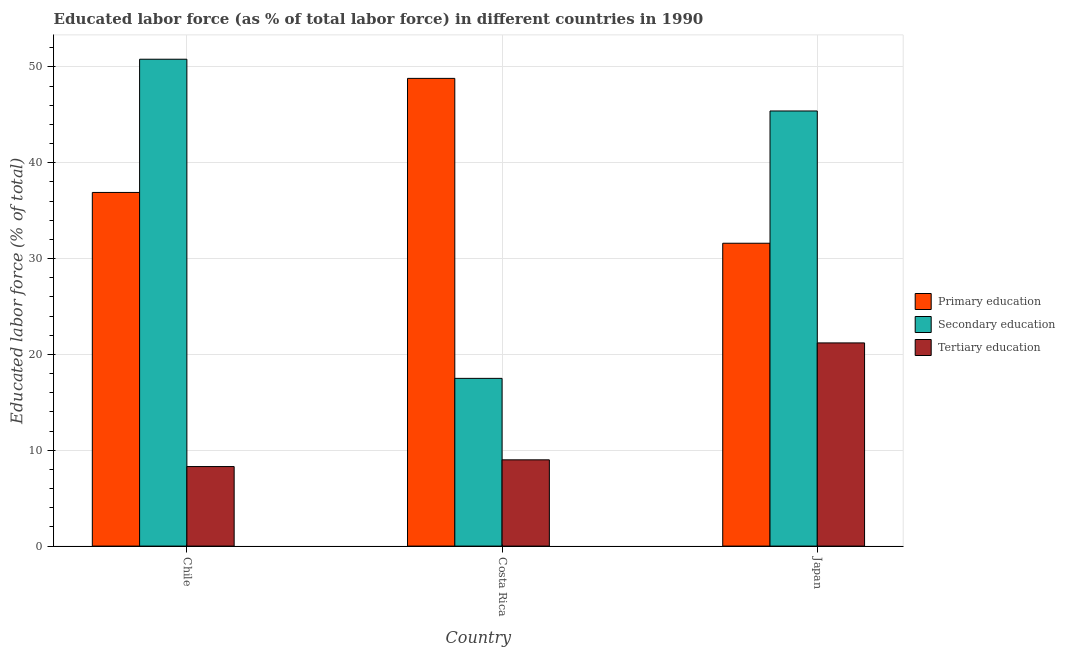How many groups of bars are there?
Make the answer very short. 3. Are the number of bars per tick equal to the number of legend labels?
Make the answer very short. Yes. How many bars are there on the 3rd tick from the right?
Make the answer very short. 3. What is the label of the 2nd group of bars from the left?
Keep it short and to the point. Costa Rica. What is the percentage of labor force who received primary education in Japan?
Ensure brevity in your answer.  31.6. Across all countries, what is the maximum percentage of labor force who received primary education?
Offer a terse response. 48.8. In which country was the percentage of labor force who received tertiary education maximum?
Ensure brevity in your answer.  Japan. What is the total percentage of labor force who received secondary education in the graph?
Provide a succinct answer. 113.7. What is the difference between the percentage of labor force who received secondary education in Chile and that in Costa Rica?
Your answer should be very brief. 33.3. What is the difference between the percentage of labor force who received primary education in Chile and the percentage of labor force who received tertiary education in Costa Rica?
Provide a short and direct response. 27.9. What is the average percentage of labor force who received secondary education per country?
Keep it short and to the point. 37.9. What is the difference between the percentage of labor force who received tertiary education and percentage of labor force who received secondary education in Japan?
Offer a very short reply. -24.2. What is the ratio of the percentage of labor force who received secondary education in Costa Rica to that in Japan?
Your answer should be compact. 0.39. Is the difference between the percentage of labor force who received primary education in Chile and Costa Rica greater than the difference between the percentage of labor force who received secondary education in Chile and Costa Rica?
Provide a succinct answer. No. What is the difference between the highest and the second highest percentage of labor force who received tertiary education?
Your answer should be very brief. 12.2. What is the difference between the highest and the lowest percentage of labor force who received primary education?
Make the answer very short. 17.2. What does the 1st bar from the left in Chile represents?
Your answer should be very brief. Primary education. Is it the case that in every country, the sum of the percentage of labor force who received primary education and percentage of labor force who received secondary education is greater than the percentage of labor force who received tertiary education?
Your answer should be very brief. Yes. How many bars are there?
Provide a succinct answer. 9. Are all the bars in the graph horizontal?
Your answer should be very brief. No. How many countries are there in the graph?
Your response must be concise. 3. Are the values on the major ticks of Y-axis written in scientific E-notation?
Give a very brief answer. No. Does the graph contain any zero values?
Your answer should be very brief. No. Where does the legend appear in the graph?
Your answer should be compact. Center right. How are the legend labels stacked?
Give a very brief answer. Vertical. What is the title of the graph?
Make the answer very short. Educated labor force (as % of total labor force) in different countries in 1990. What is the label or title of the Y-axis?
Give a very brief answer. Educated labor force (% of total). What is the Educated labor force (% of total) of Primary education in Chile?
Provide a succinct answer. 36.9. What is the Educated labor force (% of total) in Secondary education in Chile?
Offer a terse response. 50.8. What is the Educated labor force (% of total) of Tertiary education in Chile?
Your answer should be very brief. 8.3. What is the Educated labor force (% of total) of Primary education in Costa Rica?
Offer a very short reply. 48.8. What is the Educated labor force (% of total) in Secondary education in Costa Rica?
Provide a succinct answer. 17.5. What is the Educated labor force (% of total) in Primary education in Japan?
Keep it short and to the point. 31.6. What is the Educated labor force (% of total) of Secondary education in Japan?
Make the answer very short. 45.4. What is the Educated labor force (% of total) in Tertiary education in Japan?
Offer a terse response. 21.2. Across all countries, what is the maximum Educated labor force (% of total) in Primary education?
Provide a succinct answer. 48.8. Across all countries, what is the maximum Educated labor force (% of total) in Secondary education?
Provide a short and direct response. 50.8. Across all countries, what is the maximum Educated labor force (% of total) of Tertiary education?
Your answer should be compact. 21.2. Across all countries, what is the minimum Educated labor force (% of total) in Primary education?
Give a very brief answer. 31.6. Across all countries, what is the minimum Educated labor force (% of total) in Secondary education?
Make the answer very short. 17.5. Across all countries, what is the minimum Educated labor force (% of total) of Tertiary education?
Your response must be concise. 8.3. What is the total Educated labor force (% of total) in Primary education in the graph?
Your answer should be compact. 117.3. What is the total Educated labor force (% of total) in Secondary education in the graph?
Your response must be concise. 113.7. What is the total Educated labor force (% of total) of Tertiary education in the graph?
Offer a very short reply. 38.5. What is the difference between the Educated labor force (% of total) of Secondary education in Chile and that in Costa Rica?
Keep it short and to the point. 33.3. What is the difference between the Educated labor force (% of total) of Primary education in Chile and that in Japan?
Make the answer very short. 5.3. What is the difference between the Educated labor force (% of total) in Primary education in Costa Rica and that in Japan?
Offer a terse response. 17.2. What is the difference between the Educated labor force (% of total) in Secondary education in Costa Rica and that in Japan?
Offer a very short reply. -27.9. What is the difference between the Educated labor force (% of total) of Tertiary education in Costa Rica and that in Japan?
Ensure brevity in your answer.  -12.2. What is the difference between the Educated labor force (% of total) in Primary education in Chile and the Educated labor force (% of total) in Tertiary education in Costa Rica?
Your answer should be very brief. 27.9. What is the difference between the Educated labor force (% of total) of Secondary education in Chile and the Educated labor force (% of total) of Tertiary education in Costa Rica?
Your response must be concise. 41.8. What is the difference between the Educated labor force (% of total) of Primary education in Chile and the Educated labor force (% of total) of Secondary education in Japan?
Provide a short and direct response. -8.5. What is the difference between the Educated labor force (% of total) in Primary education in Chile and the Educated labor force (% of total) in Tertiary education in Japan?
Your answer should be very brief. 15.7. What is the difference between the Educated labor force (% of total) of Secondary education in Chile and the Educated labor force (% of total) of Tertiary education in Japan?
Your answer should be compact. 29.6. What is the difference between the Educated labor force (% of total) of Primary education in Costa Rica and the Educated labor force (% of total) of Secondary education in Japan?
Keep it short and to the point. 3.4. What is the difference between the Educated labor force (% of total) in Primary education in Costa Rica and the Educated labor force (% of total) in Tertiary education in Japan?
Offer a terse response. 27.6. What is the average Educated labor force (% of total) of Primary education per country?
Provide a succinct answer. 39.1. What is the average Educated labor force (% of total) of Secondary education per country?
Offer a terse response. 37.9. What is the average Educated labor force (% of total) in Tertiary education per country?
Your answer should be compact. 12.83. What is the difference between the Educated labor force (% of total) of Primary education and Educated labor force (% of total) of Secondary education in Chile?
Keep it short and to the point. -13.9. What is the difference between the Educated labor force (% of total) of Primary education and Educated labor force (% of total) of Tertiary education in Chile?
Offer a very short reply. 28.6. What is the difference between the Educated labor force (% of total) of Secondary education and Educated labor force (% of total) of Tertiary education in Chile?
Provide a short and direct response. 42.5. What is the difference between the Educated labor force (% of total) in Primary education and Educated labor force (% of total) in Secondary education in Costa Rica?
Your answer should be very brief. 31.3. What is the difference between the Educated labor force (% of total) of Primary education and Educated labor force (% of total) of Tertiary education in Costa Rica?
Offer a very short reply. 39.8. What is the difference between the Educated labor force (% of total) in Primary education and Educated labor force (% of total) in Tertiary education in Japan?
Keep it short and to the point. 10.4. What is the difference between the Educated labor force (% of total) of Secondary education and Educated labor force (% of total) of Tertiary education in Japan?
Offer a very short reply. 24.2. What is the ratio of the Educated labor force (% of total) in Primary education in Chile to that in Costa Rica?
Your response must be concise. 0.76. What is the ratio of the Educated labor force (% of total) in Secondary education in Chile to that in Costa Rica?
Make the answer very short. 2.9. What is the ratio of the Educated labor force (% of total) in Tertiary education in Chile to that in Costa Rica?
Provide a succinct answer. 0.92. What is the ratio of the Educated labor force (% of total) in Primary education in Chile to that in Japan?
Provide a short and direct response. 1.17. What is the ratio of the Educated labor force (% of total) in Secondary education in Chile to that in Japan?
Ensure brevity in your answer.  1.12. What is the ratio of the Educated labor force (% of total) of Tertiary education in Chile to that in Japan?
Keep it short and to the point. 0.39. What is the ratio of the Educated labor force (% of total) of Primary education in Costa Rica to that in Japan?
Give a very brief answer. 1.54. What is the ratio of the Educated labor force (% of total) in Secondary education in Costa Rica to that in Japan?
Give a very brief answer. 0.39. What is the ratio of the Educated labor force (% of total) of Tertiary education in Costa Rica to that in Japan?
Your response must be concise. 0.42. What is the difference between the highest and the lowest Educated labor force (% of total) in Primary education?
Offer a terse response. 17.2. What is the difference between the highest and the lowest Educated labor force (% of total) of Secondary education?
Give a very brief answer. 33.3. What is the difference between the highest and the lowest Educated labor force (% of total) in Tertiary education?
Your response must be concise. 12.9. 